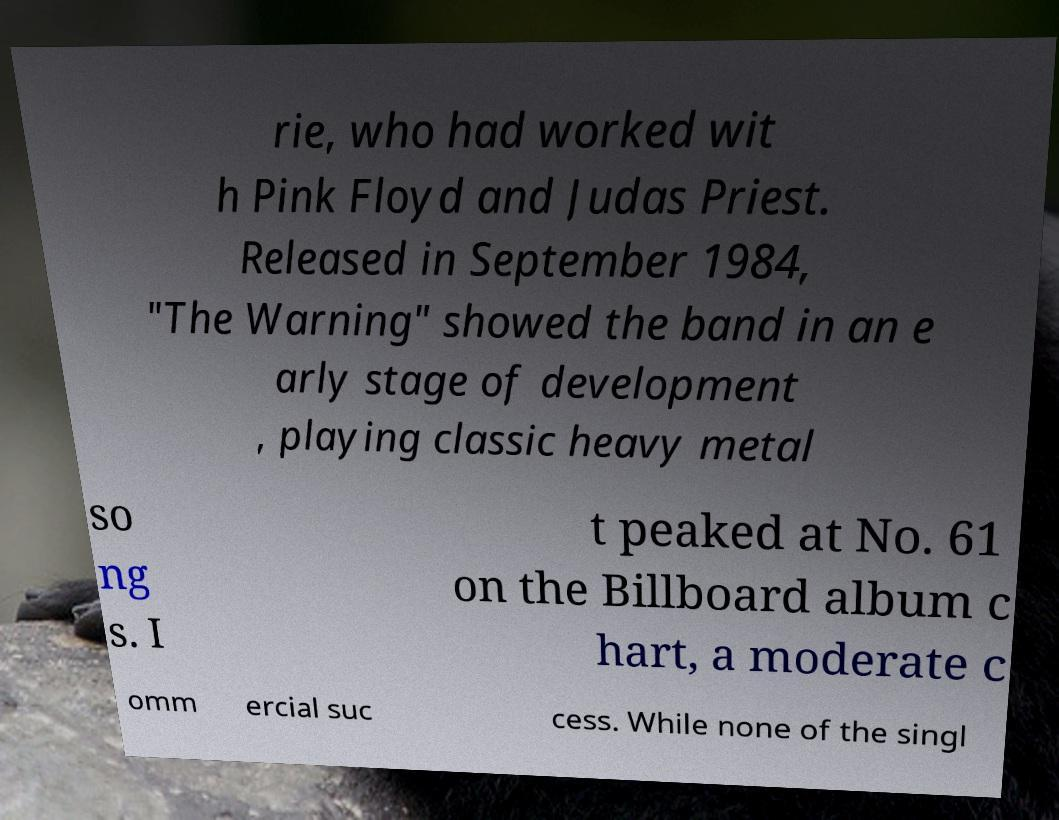Could you assist in decoding the text presented in this image and type it out clearly? rie, who had worked wit h Pink Floyd and Judas Priest. Released in September 1984, "The Warning" showed the band in an e arly stage of development , playing classic heavy metal so ng s. I t peaked at No. 61 on the Billboard album c hart, a moderate c omm ercial suc cess. While none of the singl 